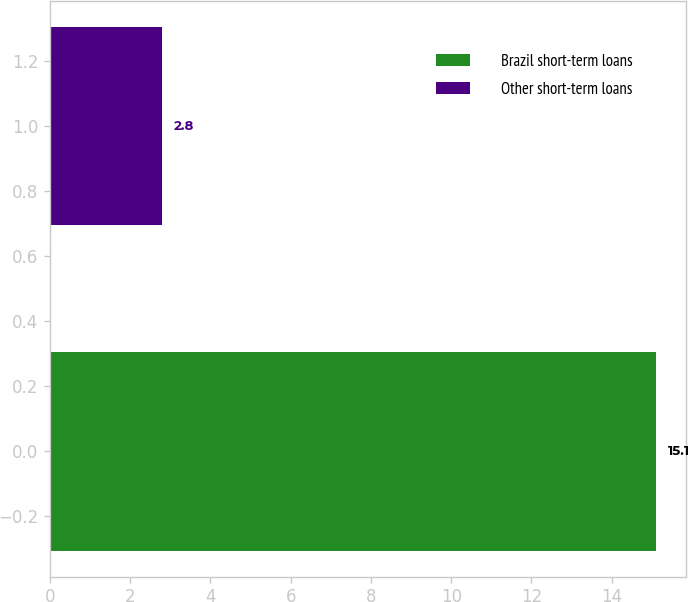<chart> <loc_0><loc_0><loc_500><loc_500><bar_chart><fcel>Brazil short-term loans<fcel>Other short-term loans<nl><fcel>15.1<fcel>2.8<nl></chart> 